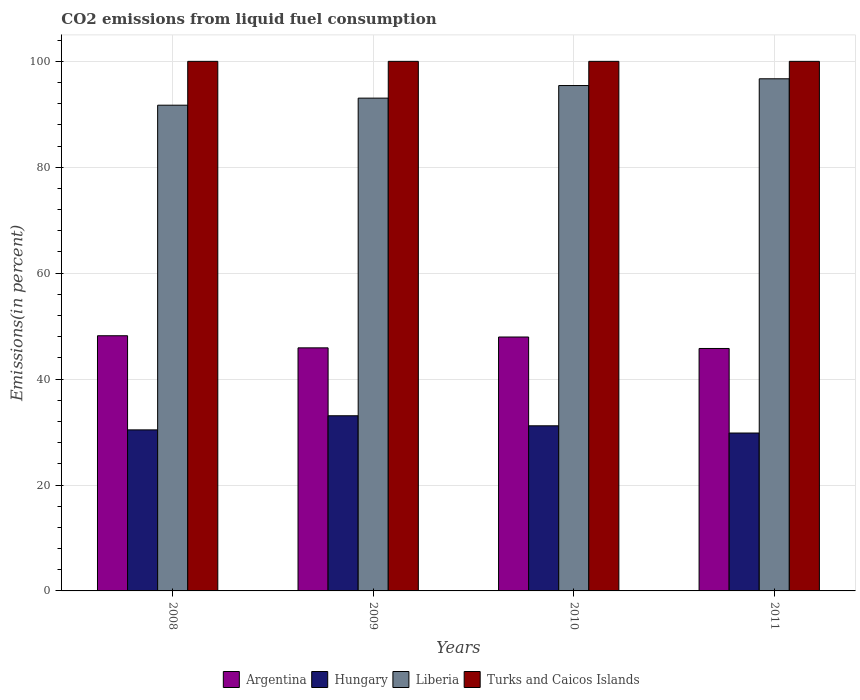How many different coloured bars are there?
Your answer should be compact. 4. Are the number of bars on each tick of the X-axis equal?
Provide a short and direct response. Yes. How many bars are there on the 3rd tick from the left?
Your answer should be compact. 4. What is the total CO2 emitted in Liberia in 2010?
Offer a terse response. 95.43. Across all years, what is the maximum total CO2 emitted in Liberia?
Make the answer very short. 96.71. Across all years, what is the minimum total CO2 emitted in Turks and Caicos Islands?
Offer a terse response. 100. In which year was the total CO2 emitted in Argentina maximum?
Make the answer very short. 2008. In which year was the total CO2 emitted in Argentina minimum?
Offer a very short reply. 2011. What is the total total CO2 emitted in Liberia in the graph?
Your response must be concise. 376.92. What is the difference between the total CO2 emitted in Argentina in 2008 and that in 2010?
Your answer should be compact. 0.24. What is the difference between the total CO2 emitted in Turks and Caicos Islands in 2010 and the total CO2 emitted in Argentina in 2009?
Offer a terse response. 54.1. What is the average total CO2 emitted in Liberia per year?
Provide a succinct answer. 94.23. In the year 2011, what is the difference between the total CO2 emitted in Hungary and total CO2 emitted in Liberia?
Make the answer very short. -66.89. What is the ratio of the total CO2 emitted in Liberia in 2008 to that in 2011?
Provide a short and direct response. 0.95. What is the difference between the highest and the second highest total CO2 emitted in Liberia?
Give a very brief answer. 1.27. In how many years, is the total CO2 emitted in Liberia greater than the average total CO2 emitted in Liberia taken over all years?
Offer a very short reply. 2. What does the 3rd bar from the left in 2010 represents?
Your answer should be compact. Liberia. What does the 2nd bar from the right in 2011 represents?
Your answer should be compact. Liberia. Are all the bars in the graph horizontal?
Offer a terse response. No. Where does the legend appear in the graph?
Provide a succinct answer. Bottom center. How are the legend labels stacked?
Give a very brief answer. Horizontal. What is the title of the graph?
Ensure brevity in your answer.  CO2 emissions from liquid fuel consumption. Does "Gambia, The" appear as one of the legend labels in the graph?
Make the answer very short. No. What is the label or title of the Y-axis?
Provide a short and direct response. Emissions(in percent). What is the Emissions(in percent) of Argentina in 2008?
Offer a terse response. 48.19. What is the Emissions(in percent) in Hungary in 2008?
Provide a short and direct response. 30.41. What is the Emissions(in percent) in Liberia in 2008?
Your answer should be very brief. 91.72. What is the Emissions(in percent) of Turks and Caicos Islands in 2008?
Your answer should be compact. 100. What is the Emissions(in percent) of Argentina in 2009?
Ensure brevity in your answer.  45.9. What is the Emissions(in percent) in Hungary in 2009?
Provide a succinct answer. 33.08. What is the Emissions(in percent) of Liberia in 2009?
Keep it short and to the point. 93.06. What is the Emissions(in percent) in Argentina in 2010?
Provide a succinct answer. 47.95. What is the Emissions(in percent) in Hungary in 2010?
Your answer should be compact. 31.18. What is the Emissions(in percent) of Liberia in 2010?
Provide a succinct answer. 95.43. What is the Emissions(in percent) of Argentina in 2011?
Your response must be concise. 45.78. What is the Emissions(in percent) of Hungary in 2011?
Offer a terse response. 29.82. What is the Emissions(in percent) in Liberia in 2011?
Your answer should be very brief. 96.71. Across all years, what is the maximum Emissions(in percent) in Argentina?
Keep it short and to the point. 48.19. Across all years, what is the maximum Emissions(in percent) of Hungary?
Provide a short and direct response. 33.08. Across all years, what is the maximum Emissions(in percent) in Liberia?
Provide a succinct answer. 96.71. Across all years, what is the maximum Emissions(in percent) of Turks and Caicos Islands?
Your answer should be very brief. 100. Across all years, what is the minimum Emissions(in percent) in Argentina?
Keep it short and to the point. 45.78. Across all years, what is the minimum Emissions(in percent) in Hungary?
Your response must be concise. 29.82. Across all years, what is the minimum Emissions(in percent) in Liberia?
Offer a terse response. 91.72. Across all years, what is the minimum Emissions(in percent) of Turks and Caicos Islands?
Give a very brief answer. 100. What is the total Emissions(in percent) of Argentina in the graph?
Provide a short and direct response. 187.81. What is the total Emissions(in percent) in Hungary in the graph?
Keep it short and to the point. 124.48. What is the total Emissions(in percent) of Liberia in the graph?
Provide a succinct answer. 376.92. What is the total Emissions(in percent) of Turks and Caicos Islands in the graph?
Keep it short and to the point. 400. What is the difference between the Emissions(in percent) of Argentina in 2008 and that in 2009?
Offer a very short reply. 2.28. What is the difference between the Emissions(in percent) of Hungary in 2008 and that in 2009?
Keep it short and to the point. -2.67. What is the difference between the Emissions(in percent) of Liberia in 2008 and that in 2009?
Offer a very short reply. -1.34. What is the difference between the Emissions(in percent) of Argentina in 2008 and that in 2010?
Make the answer very short. 0.24. What is the difference between the Emissions(in percent) in Hungary in 2008 and that in 2010?
Offer a terse response. -0.77. What is the difference between the Emissions(in percent) of Liberia in 2008 and that in 2010?
Offer a very short reply. -3.71. What is the difference between the Emissions(in percent) of Argentina in 2008 and that in 2011?
Keep it short and to the point. 2.4. What is the difference between the Emissions(in percent) of Hungary in 2008 and that in 2011?
Your response must be concise. 0.59. What is the difference between the Emissions(in percent) in Liberia in 2008 and that in 2011?
Make the answer very short. -4.99. What is the difference between the Emissions(in percent) in Turks and Caicos Islands in 2008 and that in 2011?
Offer a terse response. 0. What is the difference between the Emissions(in percent) of Argentina in 2009 and that in 2010?
Ensure brevity in your answer.  -2.05. What is the difference between the Emissions(in percent) in Hungary in 2009 and that in 2010?
Your answer should be compact. 1.9. What is the difference between the Emissions(in percent) of Liberia in 2009 and that in 2010?
Provide a short and direct response. -2.38. What is the difference between the Emissions(in percent) in Turks and Caicos Islands in 2009 and that in 2010?
Provide a succinct answer. 0. What is the difference between the Emissions(in percent) in Argentina in 2009 and that in 2011?
Keep it short and to the point. 0.12. What is the difference between the Emissions(in percent) in Hungary in 2009 and that in 2011?
Your answer should be very brief. 3.26. What is the difference between the Emissions(in percent) of Liberia in 2009 and that in 2011?
Your answer should be compact. -3.65. What is the difference between the Emissions(in percent) in Argentina in 2010 and that in 2011?
Your answer should be compact. 2.17. What is the difference between the Emissions(in percent) of Hungary in 2010 and that in 2011?
Offer a terse response. 1.36. What is the difference between the Emissions(in percent) in Liberia in 2010 and that in 2011?
Provide a succinct answer. -1.27. What is the difference between the Emissions(in percent) of Turks and Caicos Islands in 2010 and that in 2011?
Your answer should be compact. 0. What is the difference between the Emissions(in percent) of Argentina in 2008 and the Emissions(in percent) of Hungary in 2009?
Give a very brief answer. 15.11. What is the difference between the Emissions(in percent) of Argentina in 2008 and the Emissions(in percent) of Liberia in 2009?
Make the answer very short. -44.87. What is the difference between the Emissions(in percent) of Argentina in 2008 and the Emissions(in percent) of Turks and Caicos Islands in 2009?
Your response must be concise. -51.81. What is the difference between the Emissions(in percent) in Hungary in 2008 and the Emissions(in percent) in Liberia in 2009?
Offer a terse response. -62.65. What is the difference between the Emissions(in percent) in Hungary in 2008 and the Emissions(in percent) in Turks and Caicos Islands in 2009?
Your response must be concise. -69.59. What is the difference between the Emissions(in percent) of Liberia in 2008 and the Emissions(in percent) of Turks and Caicos Islands in 2009?
Make the answer very short. -8.28. What is the difference between the Emissions(in percent) of Argentina in 2008 and the Emissions(in percent) of Hungary in 2010?
Provide a short and direct response. 17.01. What is the difference between the Emissions(in percent) in Argentina in 2008 and the Emissions(in percent) in Liberia in 2010?
Offer a very short reply. -47.25. What is the difference between the Emissions(in percent) of Argentina in 2008 and the Emissions(in percent) of Turks and Caicos Islands in 2010?
Offer a very short reply. -51.81. What is the difference between the Emissions(in percent) in Hungary in 2008 and the Emissions(in percent) in Liberia in 2010?
Offer a terse response. -65.02. What is the difference between the Emissions(in percent) in Hungary in 2008 and the Emissions(in percent) in Turks and Caicos Islands in 2010?
Make the answer very short. -69.59. What is the difference between the Emissions(in percent) in Liberia in 2008 and the Emissions(in percent) in Turks and Caicos Islands in 2010?
Give a very brief answer. -8.28. What is the difference between the Emissions(in percent) in Argentina in 2008 and the Emissions(in percent) in Hungary in 2011?
Ensure brevity in your answer.  18.37. What is the difference between the Emissions(in percent) of Argentina in 2008 and the Emissions(in percent) of Liberia in 2011?
Offer a very short reply. -48.52. What is the difference between the Emissions(in percent) in Argentina in 2008 and the Emissions(in percent) in Turks and Caicos Islands in 2011?
Keep it short and to the point. -51.81. What is the difference between the Emissions(in percent) in Hungary in 2008 and the Emissions(in percent) in Liberia in 2011?
Your answer should be compact. -66.3. What is the difference between the Emissions(in percent) in Hungary in 2008 and the Emissions(in percent) in Turks and Caicos Islands in 2011?
Offer a very short reply. -69.59. What is the difference between the Emissions(in percent) in Liberia in 2008 and the Emissions(in percent) in Turks and Caicos Islands in 2011?
Provide a short and direct response. -8.28. What is the difference between the Emissions(in percent) of Argentina in 2009 and the Emissions(in percent) of Hungary in 2010?
Give a very brief answer. 14.72. What is the difference between the Emissions(in percent) of Argentina in 2009 and the Emissions(in percent) of Liberia in 2010?
Offer a terse response. -49.53. What is the difference between the Emissions(in percent) in Argentina in 2009 and the Emissions(in percent) in Turks and Caicos Islands in 2010?
Provide a short and direct response. -54.1. What is the difference between the Emissions(in percent) in Hungary in 2009 and the Emissions(in percent) in Liberia in 2010?
Offer a terse response. -62.36. What is the difference between the Emissions(in percent) of Hungary in 2009 and the Emissions(in percent) of Turks and Caicos Islands in 2010?
Make the answer very short. -66.92. What is the difference between the Emissions(in percent) of Liberia in 2009 and the Emissions(in percent) of Turks and Caicos Islands in 2010?
Provide a short and direct response. -6.94. What is the difference between the Emissions(in percent) in Argentina in 2009 and the Emissions(in percent) in Hungary in 2011?
Your answer should be compact. 16.08. What is the difference between the Emissions(in percent) of Argentina in 2009 and the Emissions(in percent) of Liberia in 2011?
Your response must be concise. -50.81. What is the difference between the Emissions(in percent) in Argentina in 2009 and the Emissions(in percent) in Turks and Caicos Islands in 2011?
Provide a succinct answer. -54.1. What is the difference between the Emissions(in percent) in Hungary in 2009 and the Emissions(in percent) in Liberia in 2011?
Give a very brief answer. -63.63. What is the difference between the Emissions(in percent) in Hungary in 2009 and the Emissions(in percent) in Turks and Caicos Islands in 2011?
Your answer should be very brief. -66.92. What is the difference between the Emissions(in percent) in Liberia in 2009 and the Emissions(in percent) in Turks and Caicos Islands in 2011?
Your answer should be very brief. -6.94. What is the difference between the Emissions(in percent) of Argentina in 2010 and the Emissions(in percent) of Hungary in 2011?
Make the answer very short. 18.13. What is the difference between the Emissions(in percent) of Argentina in 2010 and the Emissions(in percent) of Liberia in 2011?
Ensure brevity in your answer.  -48.76. What is the difference between the Emissions(in percent) of Argentina in 2010 and the Emissions(in percent) of Turks and Caicos Islands in 2011?
Provide a short and direct response. -52.05. What is the difference between the Emissions(in percent) in Hungary in 2010 and the Emissions(in percent) in Liberia in 2011?
Your response must be concise. -65.53. What is the difference between the Emissions(in percent) of Hungary in 2010 and the Emissions(in percent) of Turks and Caicos Islands in 2011?
Your response must be concise. -68.82. What is the difference between the Emissions(in percent) of Liberia in 2010 and the Emissions(in percent) of Turks and Caicos Islands in 2011?
Provide a succinct answer. -4.57. What is the average Emissions(in percent) of Argentina per year?
Your answer should be very brief. 46.95. What is the average Emissions(in percent) of Hungary per year?
Your answer should be very brief. 31.12. What is the average Emissions(in percent) of Liberia per year?
Offer a terse response. 94.23. In the year 2008, what is the difference between the Emissions(in percent) in Argentina and Emissions(in percent) in Hungary?
Ensure brevity in your answer.  17.78. In the year 2008, what is the difference between the Emissions(in percent) of Argentina and Emissions(in percent) of Liberia?
Provide a short and direct response. -43.53. In the year 2008, what is the difference between the Emissions(in percent) of Argentina and Emissions(in percent) of Turks and Caicos Islands?
Offer a very short reply. -51.81. In the year 2008, what is the difference between the Emissions(in percent) of Hungary and Emissions(in percent) of Liberia?
Provide a short and direct response. -61.31. In the year 2008, what is the difference between the Emissions(in percent) in Hungary and Emissions(in percent) in Turks and Caicos Islands?
Ensure brevity in your answer.  -69.59. In the year 2008, what is the difference between the Emissions(in percent) in Liberia and Emissions(in percent) in Turks and Caicos Islands?
Ensure brevity in your answer.  -8.28. In the year 2009, what is the difference between the Emissions(in percent) of Argentina and Emissions(in percent) of Hungary?
Keep it short and to the point. 12.83. In the year 2009, what is the difference between the Emissions(in percent) in Argentina and Emissions(in percent) in Liberia?
Give a very brief answer. -47.15. In the year 2009, what is the difference between the Emissions(in percent) of Argentina and Emissions(in percent) of Turks and Caicos Islands?
Provide a succinct answer. -54.1. In the year 2009, what is the difference between the Emissions(in percent) in Hungary and Emissions(in percent) in Liberia?
Ensure brevity in your answer.  -59.98. In the year 2009, what is the difference between the Emissions(in percent) in Hungary and Emissions(in percent) in Turks and Caicos Islands?
Provide a short and direct response. -66.92. In the year 2009, what is the difference between the Emissions(in percent) in Liberia and Emissions(in percent) in Turks and Caicos Islands?
Make the answer very short. -6.94. In the year 2010, what is the difference between the Emissions(in percent) in Argentina and Emissions(in percent) in Hungary?
Keep it short and to the point. 16.77. In the year 2010, what is the difference between the Emissions(in percent) of Argentina and Emissions(in percent) of Liberia?
Your answer should be compact. -47.49. In the year 2010, what is the difference between the Emissions(in percent) in Argentina and Emissions(in percent) in Turks and Caicos Islands?
Offer a terse response. -52.05. In the year 2010, what is the difference between the Emissions(in percent) of Hungary and Emissions(in percent) of Liberia?
Provide a short and direct response. -64.25. In the year 2010, what is the difference between the Emissions(in percent) of Hungary and Emissions(in percent) of Turks and Caicos Islands?
Your answer should be very brief. -68.82. In the year 2010, what is the difference between the Emissions(in percent) in Liberia and Emissions(in percent) in Turks and Caicos Islands?
Your answer should be compact. -4.57. In the year 2011, what is the difference between the Emissions(in percent) of Argentina and Emissions(in percent) of Hungary?
Offer a terse response. 15.96. In the year 2011, what is the difference between the Emissions(in percent) in Argentina and Emissions(in percent) in Liberia?
Your response must be concise. -50.93. In the year 2011, what is the difference between the Emissions(in percent) in Argentina and Emissions(in percent) in Turks and Caicos Islands?
Your response must be concise. -54.22. In the year 2011, what is the difference between the Emissions(in percent) in Hungary and Emissions(in percent) in Liberia?
Provide a succinct answer. -66.89. In the year 2011, what is the difference between the Emissions(in percent) of Hungary and Emissions(in percent) of Turks and Caicos Islands?
Offer a very short reply. -70.18. In the year 2011, what is the difference between the Emissions(in percent) in Liberia and Emissions(in percent) in Turks and Caicos Islands?
Your response must be concise. -3.29. What is the ratio of the Emissions(in percent) of Argentina in 2008 to that in 2009?
Provide a succinct answer. 1.05. What is the ratio of the Emissions(in percent) in Hungary in 2008 to that in 2009?
Give a very brief answer. 0.92. What is the ratio of the Emissions(in percent) of Liberia in 2008 to that in 2009?
Offer a terse response. 0.99. What is the ratio of the Emissions(in percent) of Turks and Caicos Islands in 2008 to that in 2009?
Ensure brevity in your answer.  1. What is the ratio of the Emissions(in percent) of Argentina in 2008 to that in 2010?
Your answer should be compact. 1. What is the ratio of the Emissions(in percent) of Hungary in 2008 to that in 2010?
Your response must be concise. 0.98. What is the ratio of the Emissions(in percent) of Liberia in 2008 to that in 2010?
Ensure brevity in your answer.  0.96. What is the ratio of the Emissions(in percent) in Argentina in 2008 to that in 2011?
Provide a short and direct response. 1.05. What is the ratio of the Emissions(in percent) in Hungary in 2008 to that in 2011?
Your answer should be compact. 1.02. What is the ratio of the Emissions(in percent) of Liberia in 2008 to that in 2011?
Make the answer very short. 0.95. What is the ratio of the Emissions(in percent) of Turks and Caicos Islands in 2008 to that in 2011?
Your answer should be compact. 1. What is the ratio of the Emissions(in percent) of Argentina in 2009 to that in 2010?
Ensure brevity in your answer.  0.96. What is the ratio of the Emissions(in percent) of Hungary in 2009 to that in 2010?
Ensure brevity in your answer.  1.06. What is the ratio of the Emissions(in percent) in Liberia in 2009 to that in 2010?
Offer a very short reply. 0.98. What is the ratio of the Emissions(in percent) of Hungary in 2009 to that in 2011?
Give a very brief answer. 1.11. What is the ratio of the Emissions(in percent) in Liberia in 2009 to that in 2011?
Ensure brevity in your answer.  0.96. What is the ratio of the Emissions(in percent) in Turks and Caicos Islands in 2009 to that in 2011?
Offer a terse response. 1. What is the ratio of the Emissions(in percent) of Argentina in 2010 to that in 2011?
Provide a short and direct response. 1.05. What is the ratio of the Emissions(in percent) in Hungary in 2010 to that in 2011?
Your response must be concise. 1.05. What is the ratio of the Emissions(in percent) in Liberia in 2010 to that in 2011?
Your answer should be compact. 0.99. What is the difference between the highest and the second highest Emissions(in percent) in Argentina?
Offer a terse response. 0.24. What is the difference between the highest and the second highest Emissions(in percent) in Hungary?
Give a very brief answer. 1.9. What is the difference between the highest and the second highest Emissions(in percent) in Liberia?
Your answer should be very brief. 1.27. What is the difference between the highest and the lowest Emissions(in percent) in Argentina?
Ensure brevity in your answer.  2.4. What is the difference between the highest and the lowest Emissions(in percent) in Hungary?
Keep it short and to the point. 3.26. What is the difference between the highest and the lowest Emissions(in percent) of Liberia?
Offer a terse response. 4.99. 